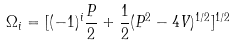Convert formula to latex. <formula><loc_0><loc_0><loc_500><loc_500>\Omega _ { i } = [ ( - 1 ) ^ { i } \frac { P } { 2 } + \frac { 1 } { 2 } ( P ^ { 2 } - 4 V ) ^ { 1 / 2 } ] ^ { 1 / 2 }</formula> 